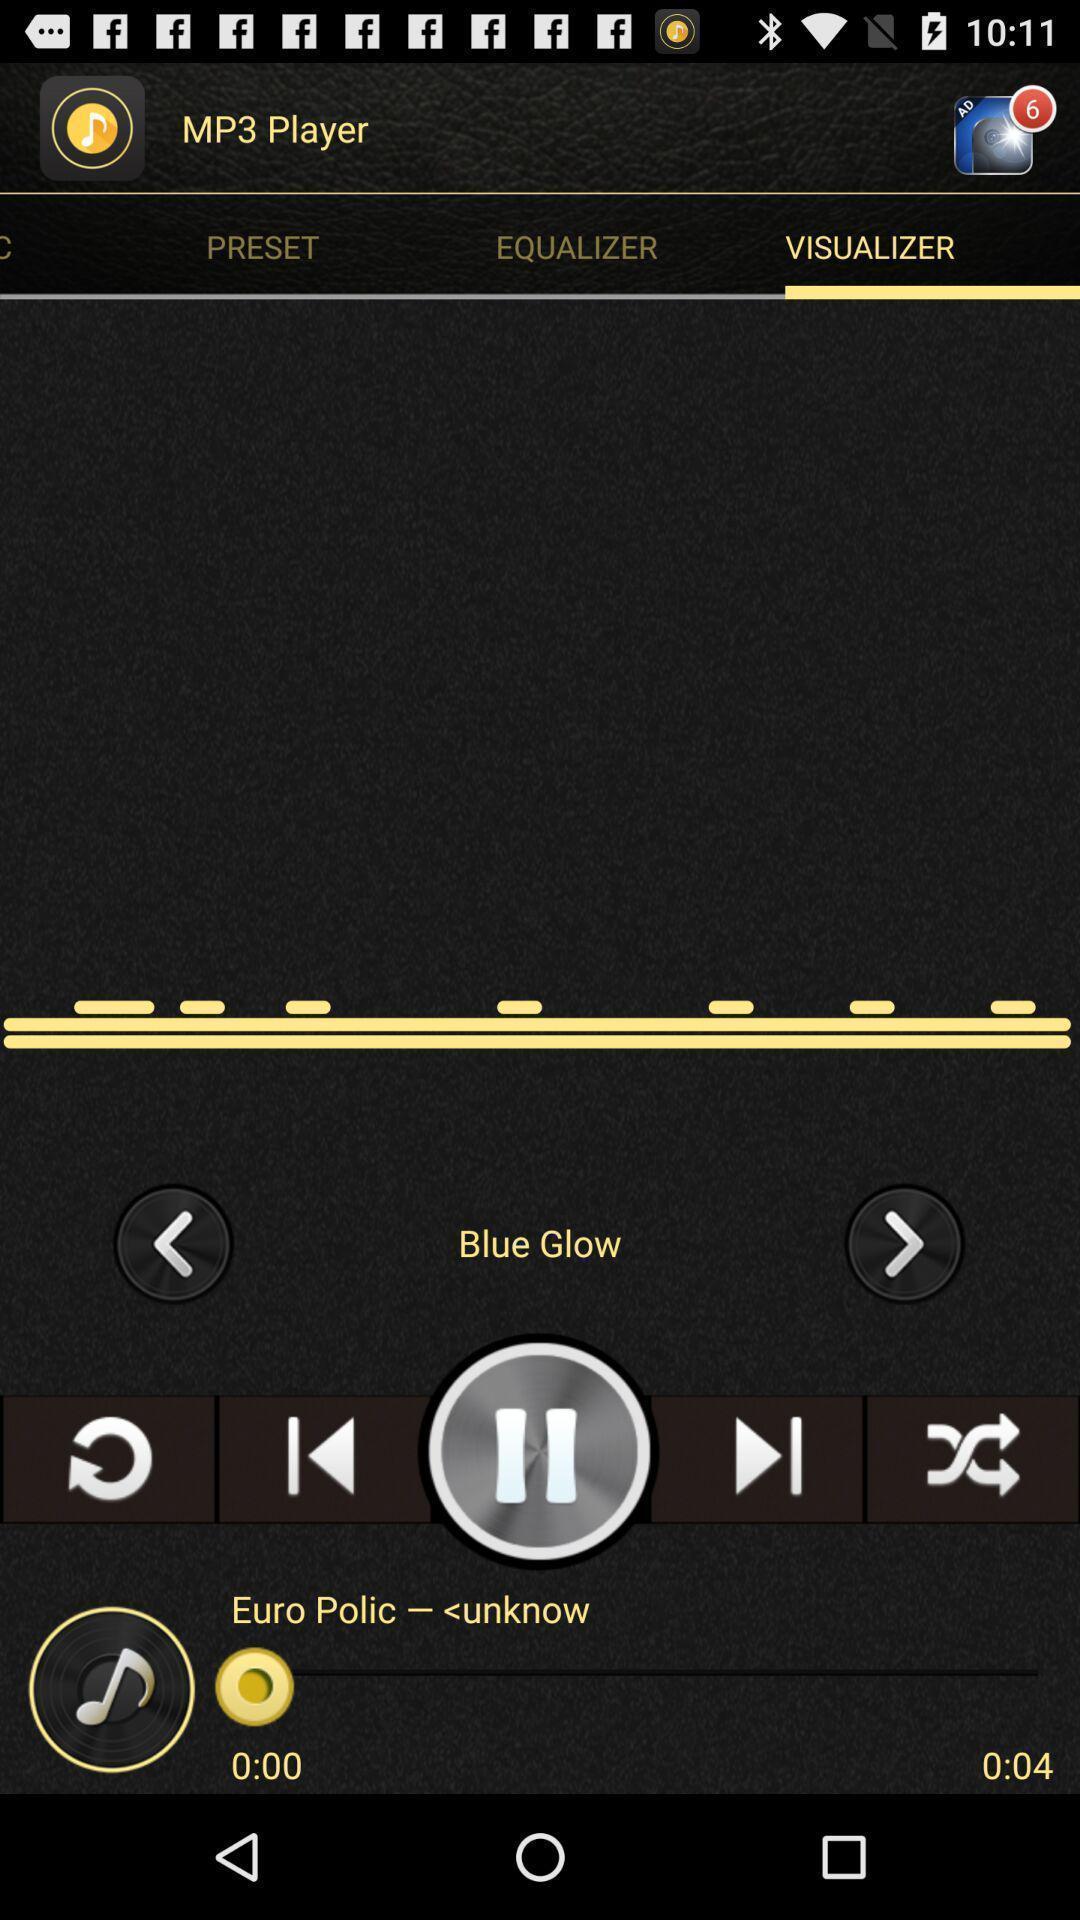Describe the key features of this screenshot. Page displaying with audio playing in music application. 